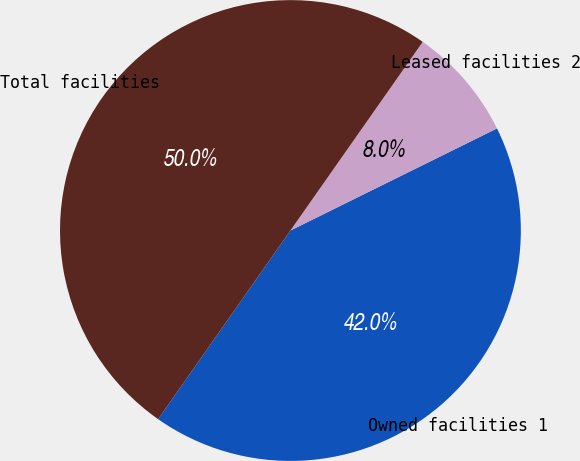Convert chart to OTSL. <chart><loc_0><loc_0><loc_500><loc_500><pie_chart><fcel>Owned facilities 1<fcel>Leased facilities 2<fcel>Total facilities<nl><fcel>42.04%<fcel>7.96%<fcel>50.0%<nl></chart> 